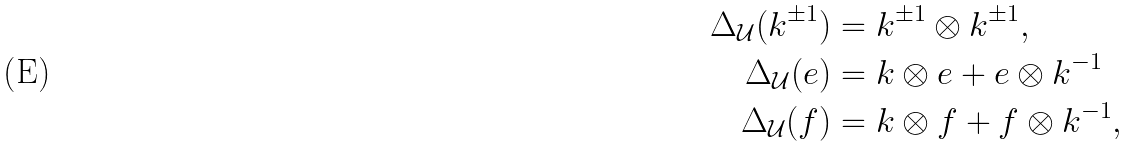<formula> <loc_0><loc_0><loc_500><loc_500>\Delta _ { \mathcal { U } } ( k ^ { \pm 1 } ) & = k ^ { \pm 1 } \otimes k ^ { \pm 1 } , \\ \Delta _ { \mathcal { U } } ( e ) & = k \otimes e + e \otimes k ^ { - 1 } \\ \Delta _ { \mathcal { U } } ( f ) & = k \otimes f + f \otimes k ^ { - 1 } ,</formula> 